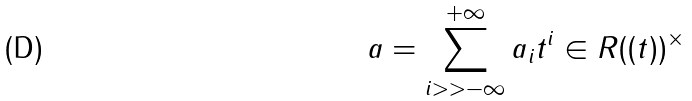<formula> <loc_0><loc_0><loc_500><loc_500>a = \sum _ { i > > - \infty } ^ { + \infty } a _ { i } t ^ { i } \in R ( ( t ) ) ^ { \times }</formula> 